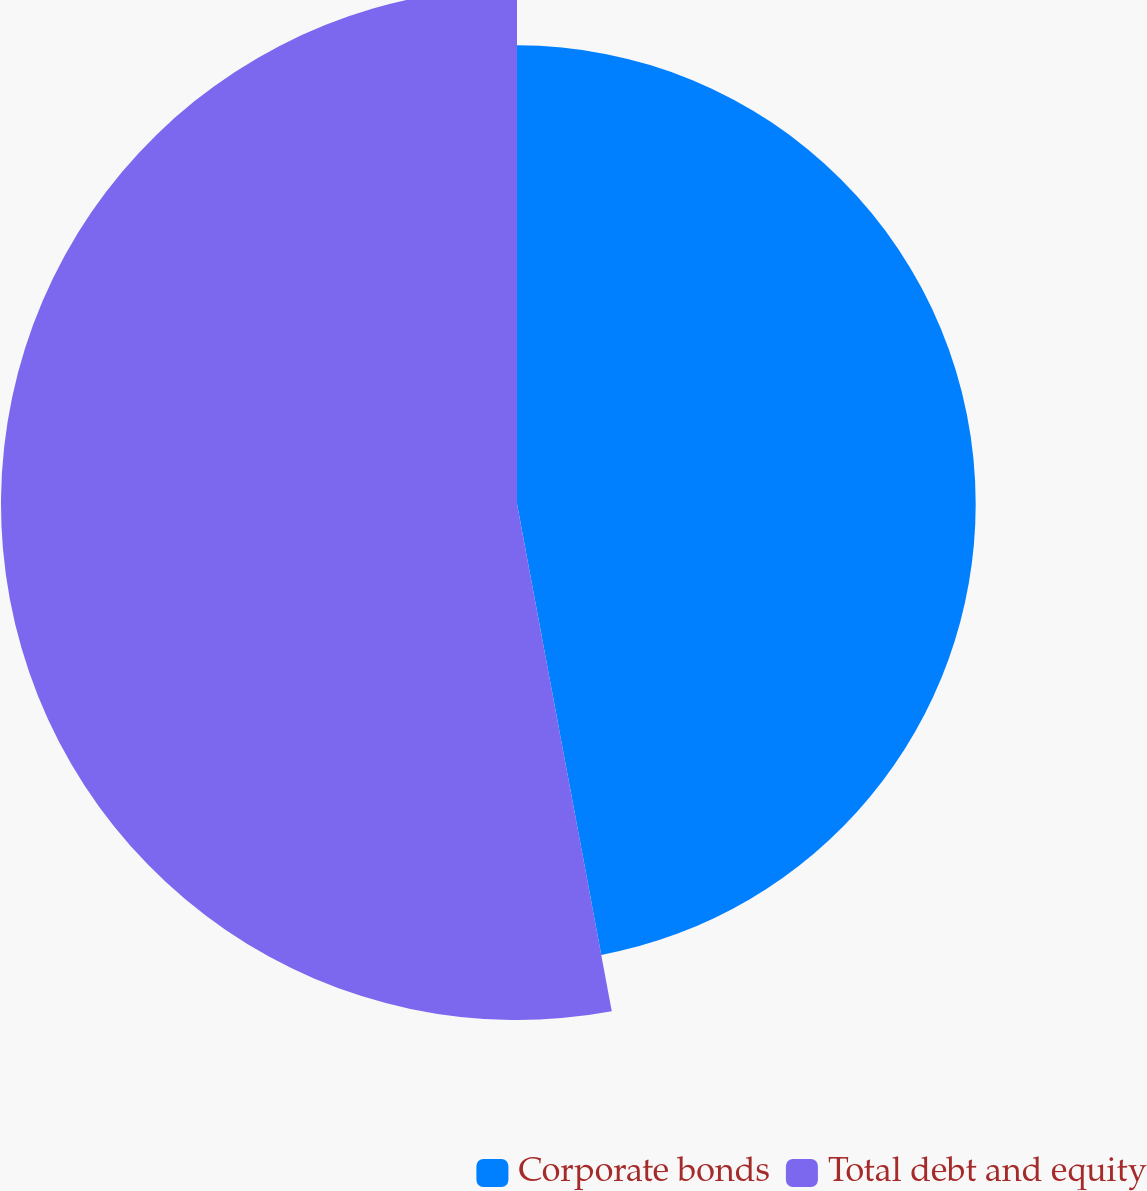Convert chart. <chart><loc_0><loc_0><loc_500><loc_500><pie_chart><fcel>Corporate bonds<fcel>Total debt and equity<nl><fcel>47.06%<fcel>52.94%<nl></chart> 